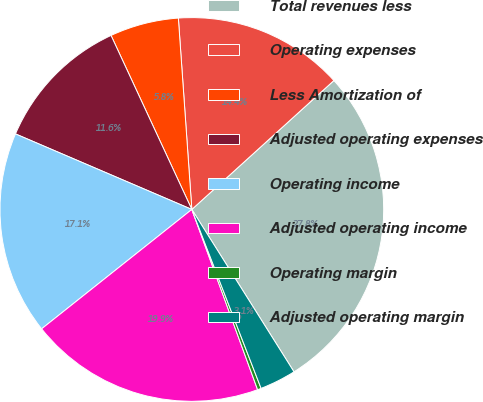<chart> <loc_0><loc_0><loc_500><loc_500><pie_chart><fcel>Total revenues less<fcel>Operating expenses<fcel>Less Amortization of<fcel>Adjusted operating expenses<fcel>Operating income<fcel>Adjusted operating income<fcel>Operating margin<fcel>Adjusted operating margin<nl><fcel>27.79%<fcel>14.39%<fcel>5.8%<fcel>11.64%<fcel>17.13%<fcel>19.88%<fcel>0.31%<fcel>3.06%<nl></chart> 